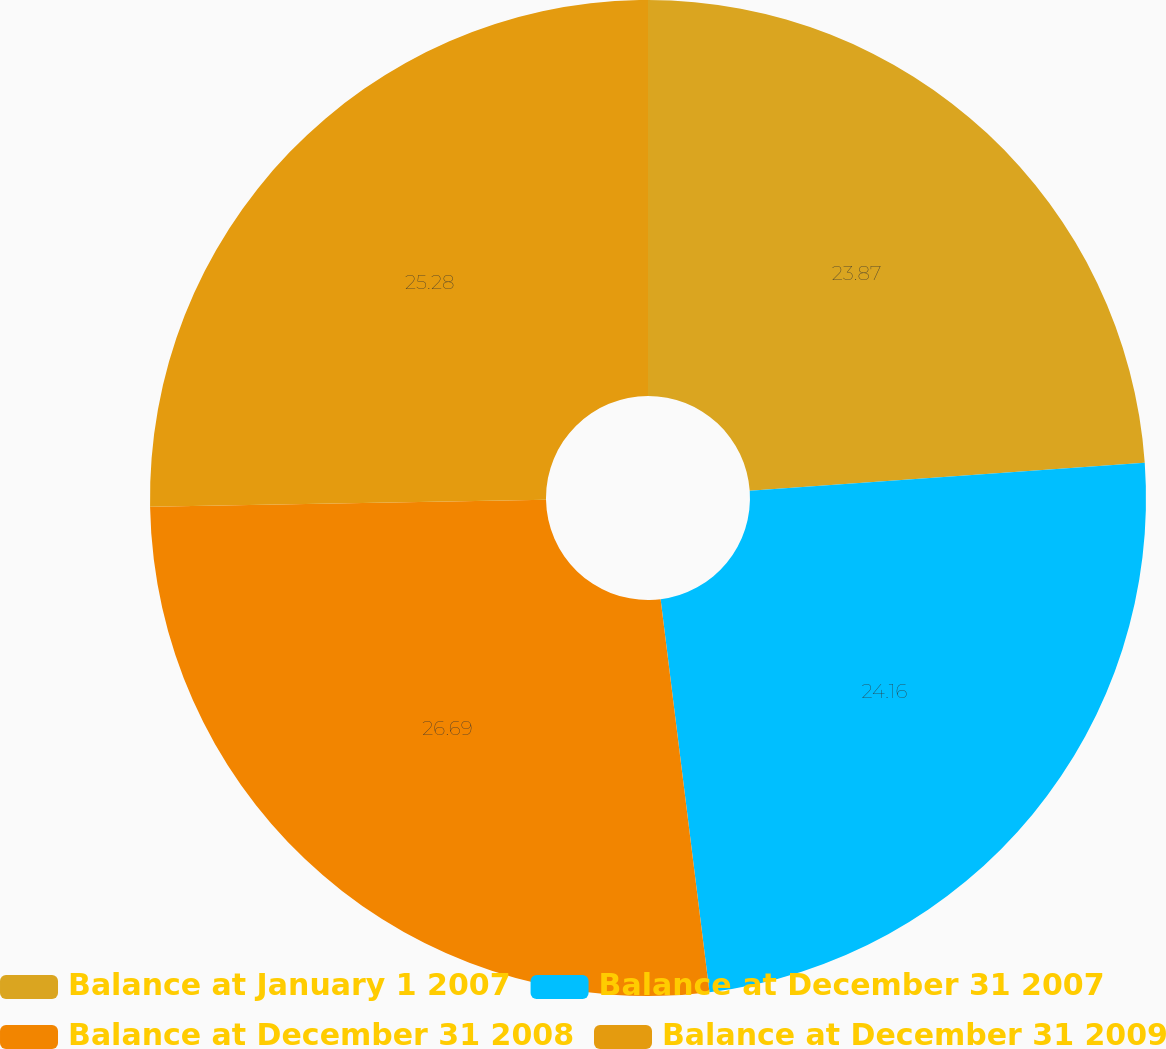Convert chart to OTSL. <chart><loc_0><loc_0><loc_500><loc_500><pie_chart><fcel>Balance at January 1 2007<fcel>Balance at December 31 2007<fcel>Balance at December 31 2008<fcel>Balance at December 31 2009<nl><fcel>23.87%<fcel>24.16%<fcel>26.69%<fcel>25.28%<nl></chart> 